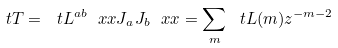<formula> <loc_0><loc_0><loc_500><loc_500>\ t T = \ t L ^ { a b } \ x x J _ { a } J _ { b } \ x x = \sum _ { m } \ t L ( m ) z ^ { - m - 2 }</formula> 